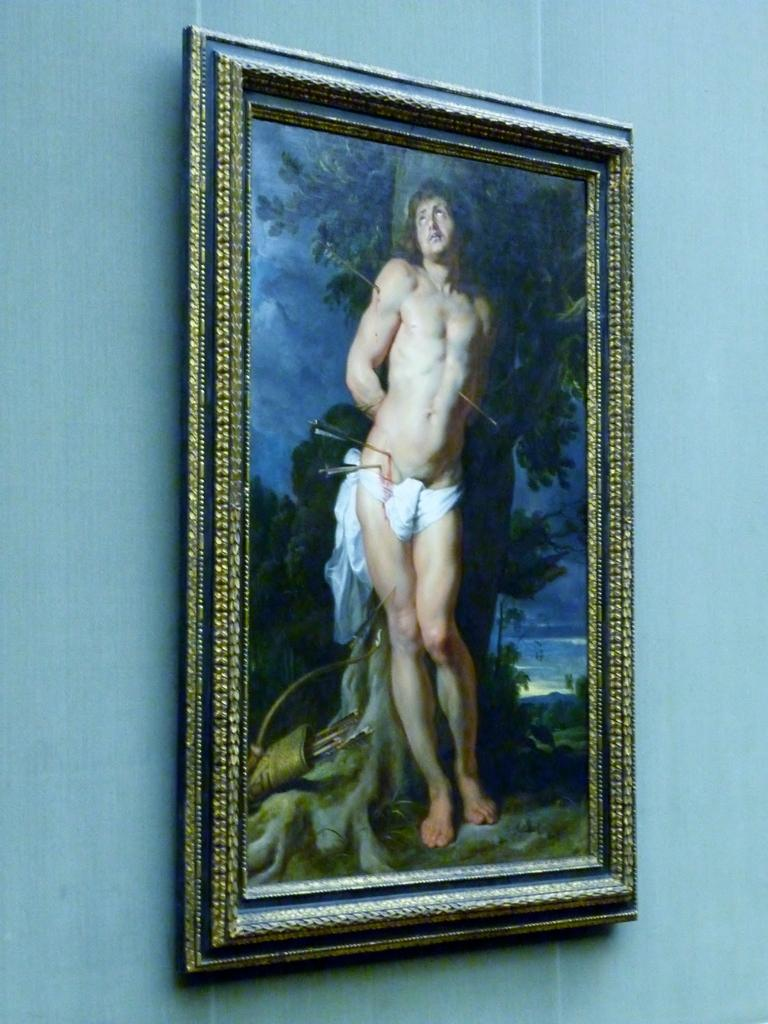What object can be seen in the image that is typically used for displaying photos? There is a photo frame in the image. Where is the photo frame located? The photo frame is on a wall. Can you see any examples of birds flying in the image? There are no birds visible in the image; it only features a photo frame on a wall. 